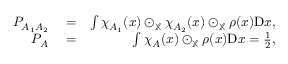Convert formula to latex. <formula><loc_0><loc_0><loc_500><loc_500>\begin{array} { r l r } { P _ { A _ { 1 } A _ { 2 } } } & = } & { \int \chi _ { A _ { 1 } } ( x ) \odot _ { \mathbb { X } } \chi _ { A _ { 2 } } ( x ) \odot _ { \mathbb { X } } \rho ( x ) D x , } \\ { P _ { A } } & = } & { \int \chi _ { A } ( x ) \odot _ { \mathbb { X } } \rho ( x ) D x = \frac { 1 } { 2 } , } \end{array}</formula> 